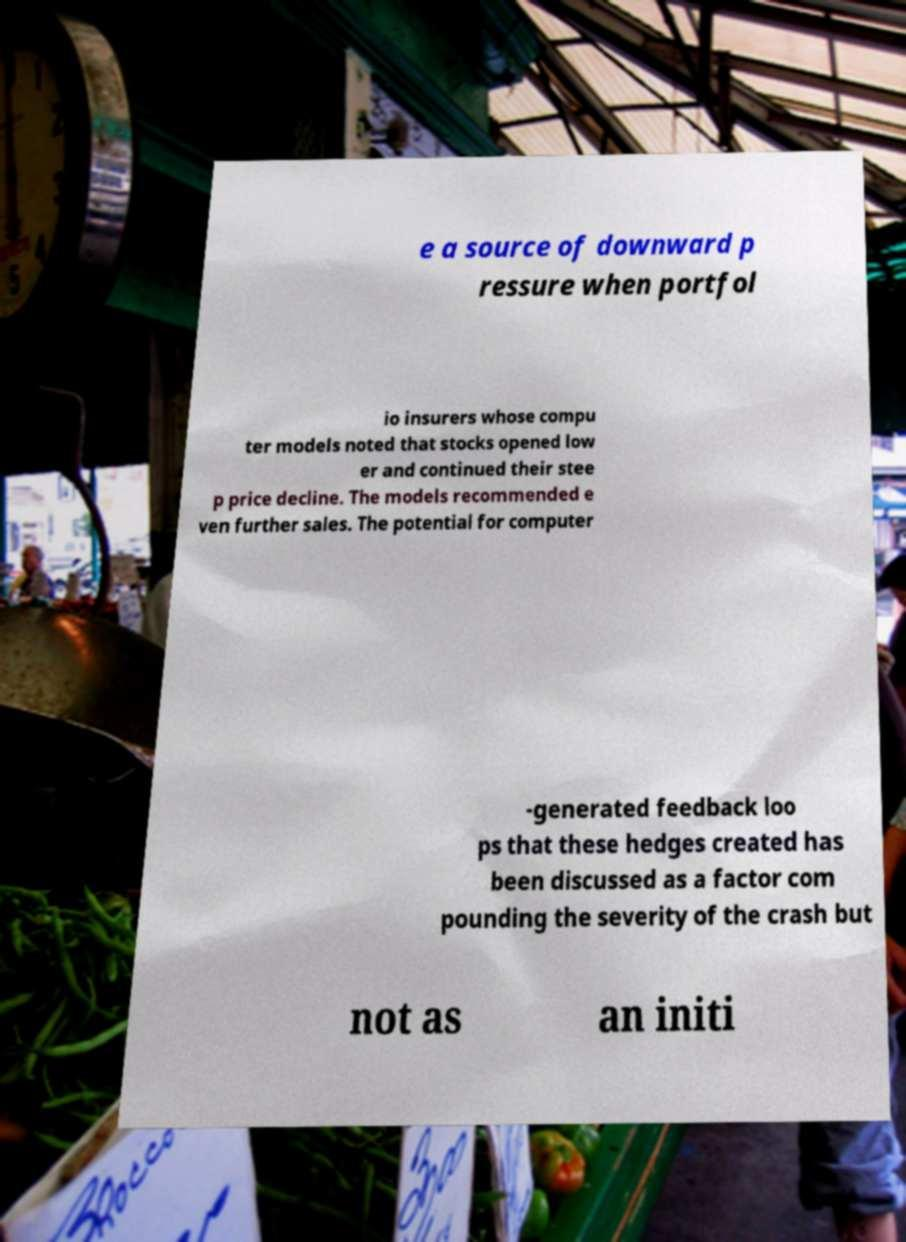Could you assist in decoding the text presented in this image and type it out clearly? e a source of downward p ressure when portfol io insurers whose compu ter models noted that stocks opened low er and continued their stee p price decline. The models recommended e ven further sales. The potential for computer -generated feedback loo ps that these hedges created has been discussed as a factor com pounding the severity of the crash but not as an initi 